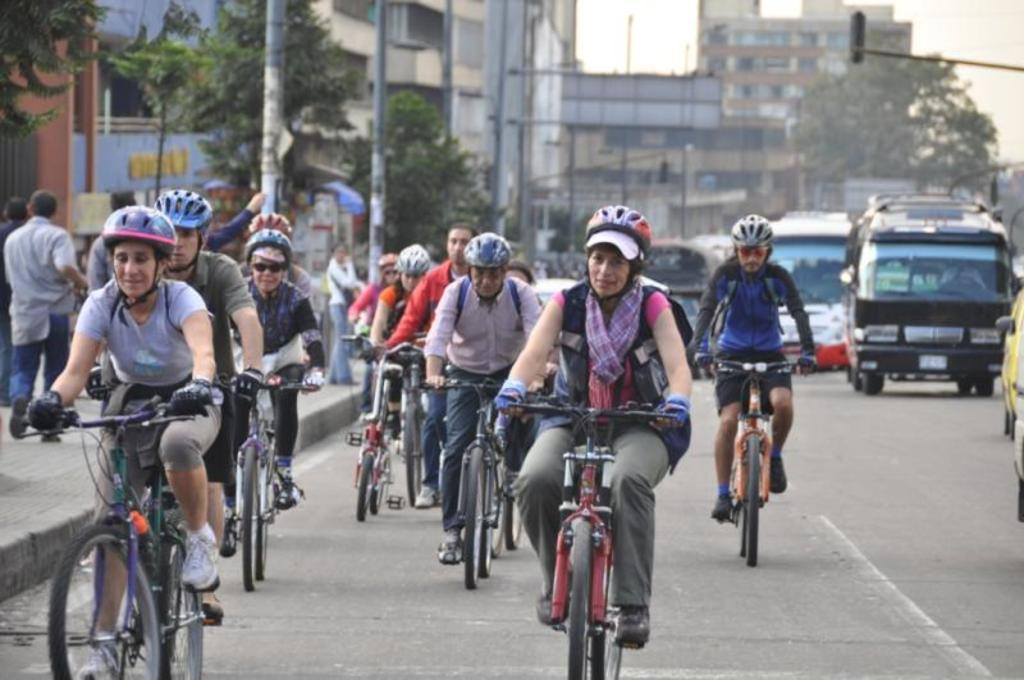What are the people in the image doing? There is a group of people riding a bicycle in the image. What safety precaution are the people taking while riding the bicycle? The people are wearing helmets. Where is the scene taking place? The scene takes place on the road. What can be seen in the background of the image? There are poles, trees, buildings, vehicles, and the sky visible in the background of the image. What type of weather can be seen in the image? The provided facts do not mention any specific weather conditions in the image. Who is the manager of the group of people riding the bicycle in the image? There is no mention of a manager or any leadership role in the image. 